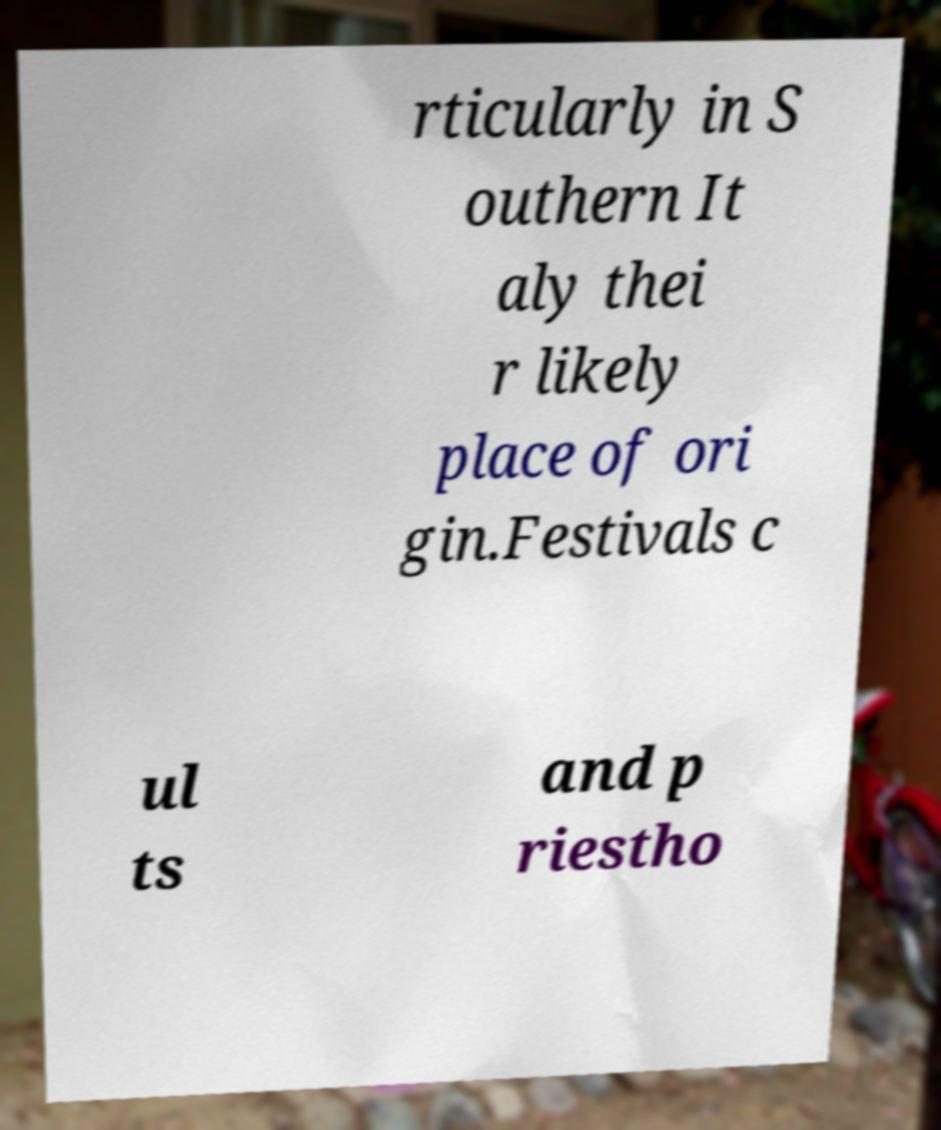Could you extract and type out the text from this image? rticularly in S outhern It aly thei r likely place of ori gin.Festivals c ul ts and p riestho 